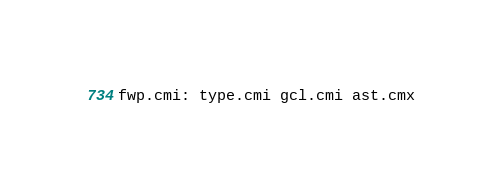<code> <loc_0><loc_0><loc_500><loc_500><_D_>fwp.cmi: type.cmi gcl.cmi ast.cmx
</code> 